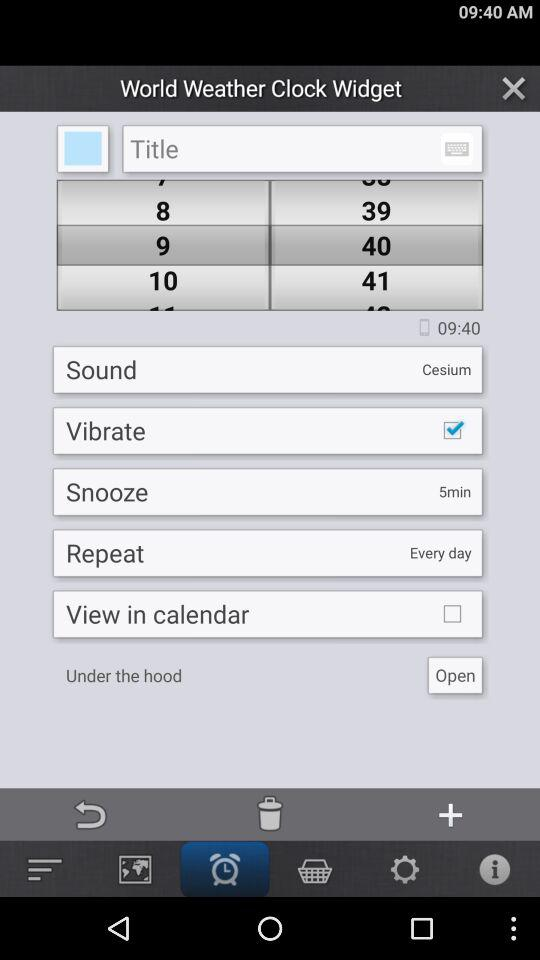What is the time selected? The selected time is 09:40. 